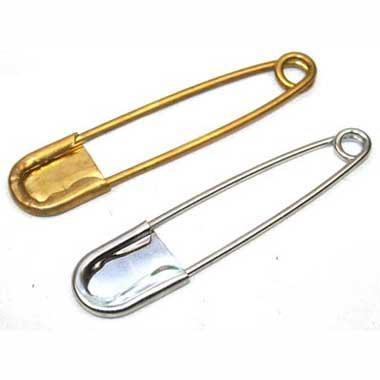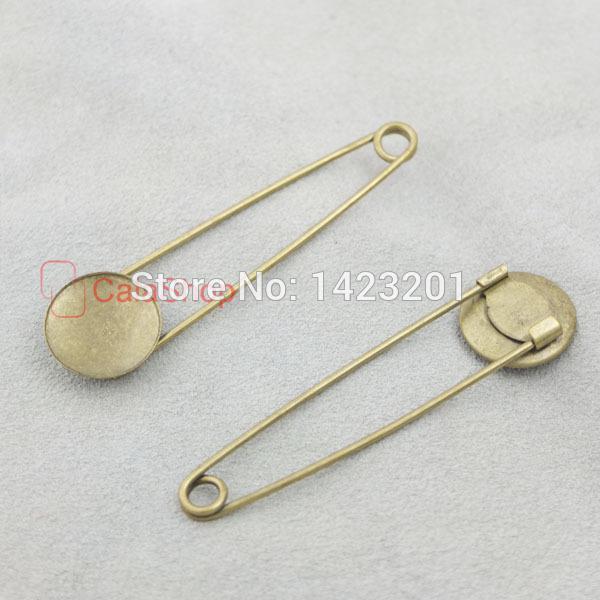The first image is the image on the left, the second image is the image on the right. For the images shown, is this caption "one of the safety pins is open." true? Answer yes or no. No. 